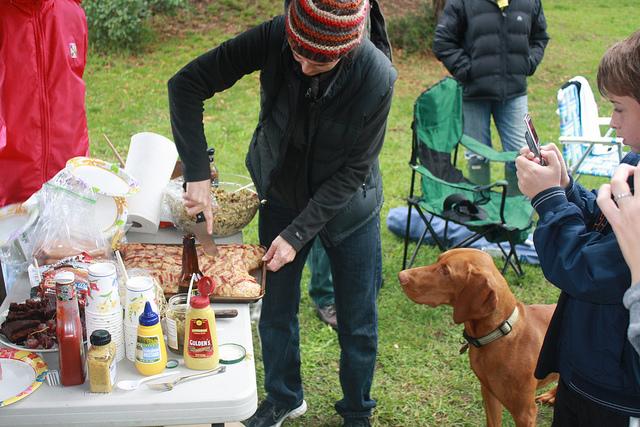What color is the grass?
Answer briefly. Green. Is it warm or cold in the pic?
Concise answer only. Cold. What is the kid doing with the cell phone?
Concise answer only. Taking picture. 